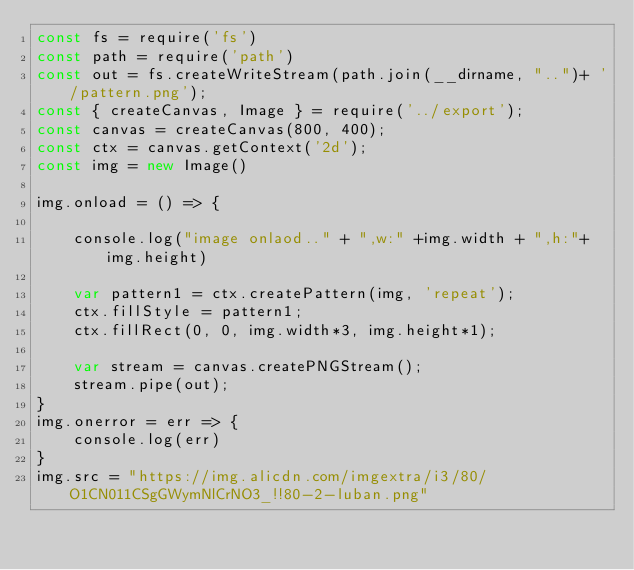Convert code to text. <code><loc_0><loc_0><loc_500><loc_500><_JavaScript_>const fs = require('fs')
const path = require('path')
const out = fs.createWriteStream(path.join(__dirname, "..")+ '/pattern.png');
const { createCanvas, Image } = require('../export');
const canvas = createCanvas(800, 400);
const ctx = canvas.getContext('2d');
const img = new Image()

img.onload = () => {

    console.log("image onlaod.." + ",w:" +img.width + ",h:"+img.height)

    var pattern1 = ctx.createPattern(img, 'repeat');
    ctx.fillStyle = pattern1;
    ctx.fillRect(0, 0, img.width*3, img.height*1);

    var stream = canvas.createPNGStream();
    stream.pipe(out);
}
img.onerror = err => {
    console.log(err)
}
img.src = "https://img.alicdn.com/imgextra/i3/80/O1CN011CSgGWymNlCrNO3_!!80-2-luban.png"</code> 